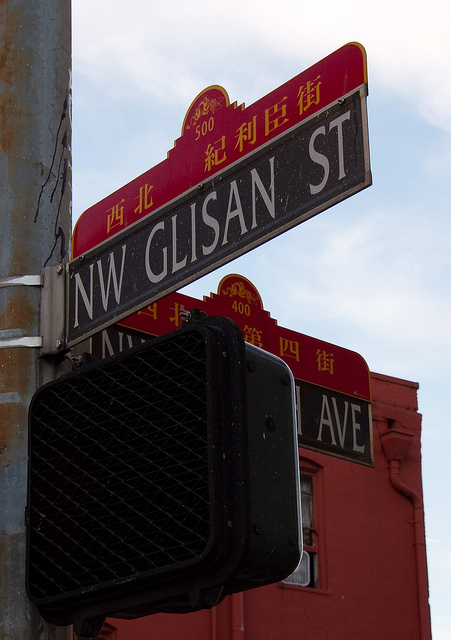<image>What city is this located? I don't know what city this is located. It could be Portland, Toronto, India, London, New York City, China, or Korea. What city is this located? It is ambiguous what city it is located because there are multiple answers given. 